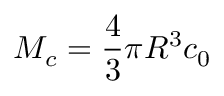Convert formula to latex. <formula><loc_0><loc_0><loc_500><loc_500>M _ { c } = \frac { 4 } { 3 } \pi R ^ { 3 } c _ { 0 }</formula> 